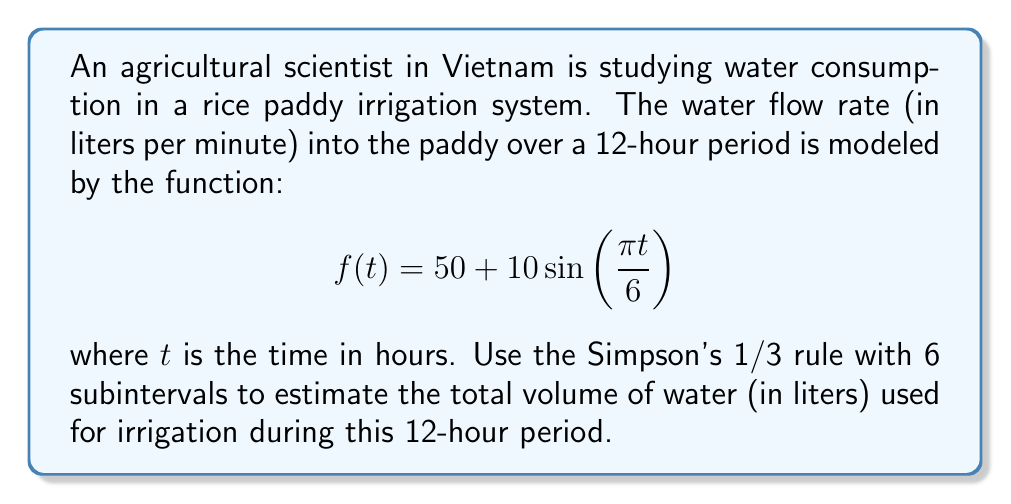Can you solve this math problem? To solve this problem, we'll use Simpson's 1/3 rule for numerical integration:

1) Simpson's 1/3 rule formula:
   $$\int_{a}^{b} f(x)dx \approx \frac{h}{3}[f(x_0) + 4f(x_1) + 2f(x_2) + 4f(x_3) + 2f(x_4) + 4f(x_5) + f(x_6)]$$
   where $h = \frac{b-a}{n}$, and $n$ is the number of subintervals (must be even).

2) In our case:
   $a = 0$, $b = 12$, $n = 6$
   $h = \frac{12-0}{6} = 2$

3) Calculate function values:
   $f(0) = 50 + 10\sin(0) = 50$
   $f(2) = 50 + 10\sin(\frac{\pi}{3}) \approx 58.66$
   $f(4) = 50 + 10\sin(\frac{2\pi}{3}) \approx 58.66$
   $f(6) = 50 + 10\sin(\pi) = 50$
   $f(8) = 50 + 10\sin(\frac{4\pi}{3}) \approx 41.34$
   $f(10) = 50 + 10\sin(\frac{5\pi}{3}) \approx 41.34$
   $f(12) = 50 + 10\sin(2\pi) = 50$

4) Apply Simpson's 1/3 rule:
   $$\frac{2}{3}[50 + 4(58.66) + 2(58.66) + 4(50) + 2(41.34) + 4(41.34) + 50]$$
   $$= \frac{2}{3}[50 + 234.64 + 117.32 + 200 + 82.68 + 165.36 + 50]$$
   $$= \frac{2}{3}(899.96) \approx 599.97$$

5) This gives us the average flow rate over the 12-hour period. To get the total volume, we multiply by the number of minutes in 12 hours:
   $599.97 \times (12 \times 60) = 431,978.4$ liters
Answer: 431,978.4 liters 